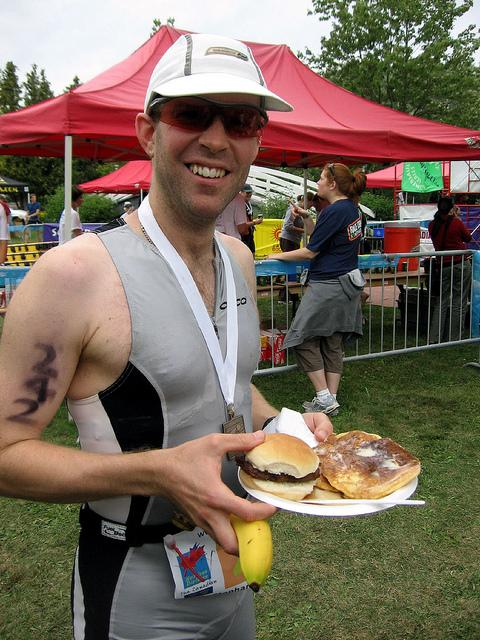Why does the man have numbers written on his arm? race 